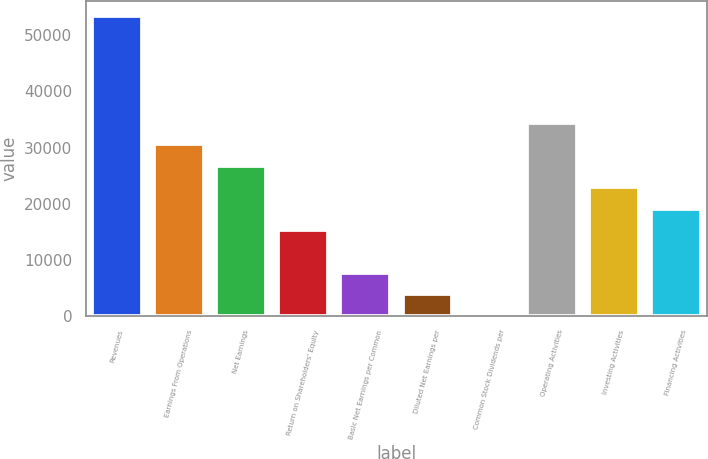Convert chart. <chart><loc_0><loc_0><loc_500><loc_500><bar_chart><fcel>Revenues<fcel>Earnings From Operations<fcel>Net Earnings<fcel>Return on Shareholders' Equity<fcel>Basic Net Earnings per Common<fcel>Diluted Net Earnings per<fcel>Common Stock Dividends per<fcel>Operating Activities<fcel>Investing Activities<fcel>Financing Activities<nl><fcel>53503.8<fcel>30573.6<fcel>26751.9<fcel>15286.8<fcel>7643.41<fcel>3821.71<fcel>0.01<fcel>34395.3<fcel>22930.2<fcel>19108.5<nl></chart> 